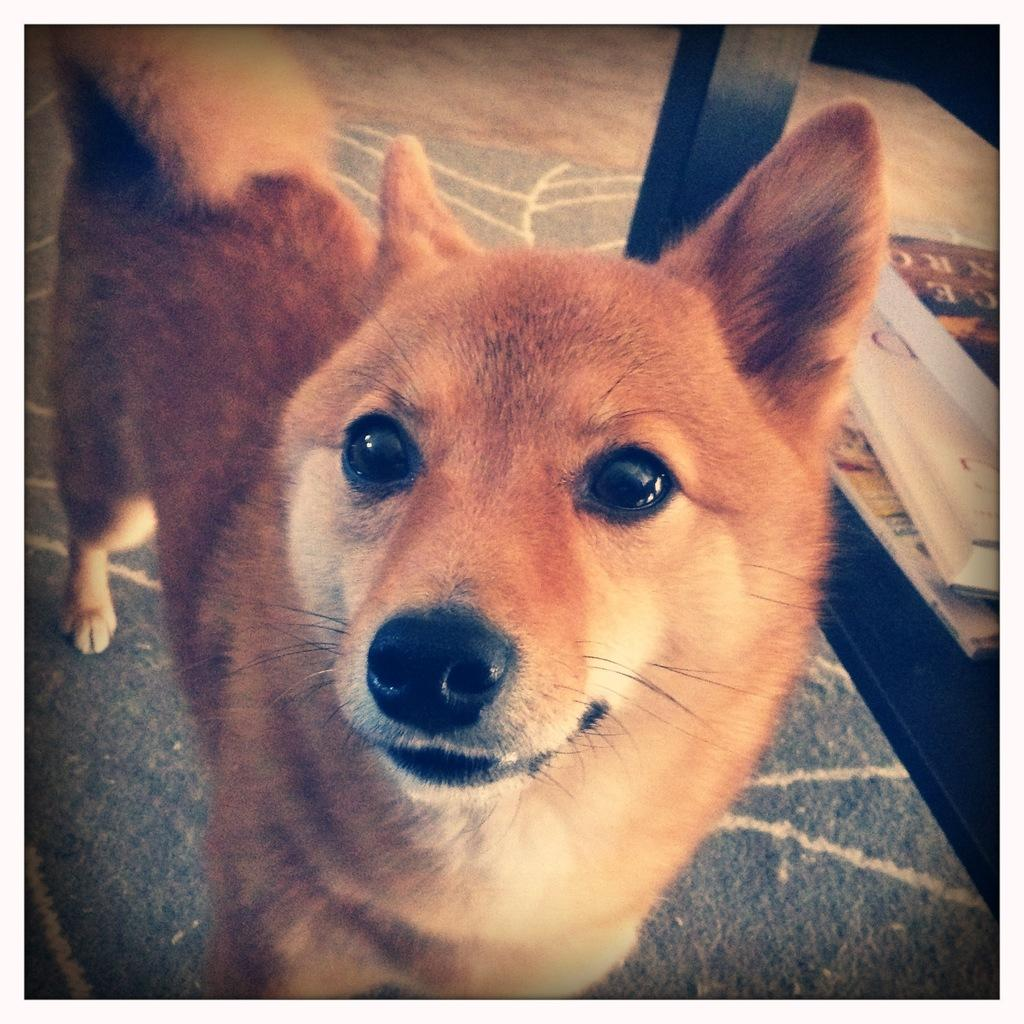What type of animal can be seen in the image? There is a dog in the image. Where is the dog located? The dog is on a mat. What is the mat placed on? The mat is placed on a floor. What wooden object is present in the image? There is a wooden object in the image. What else can be seen in the image besides the dog and the wooden object? There are books in the image. What advertisement can be seen on the dog's collar in the image? There is no advertisement on the dog's collar in the image, as the dog is not wearing a collar. 